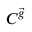<formula> <loc_0><loc_0><loc_500><loc_500>C ^ { \vec { g } }</formula> 